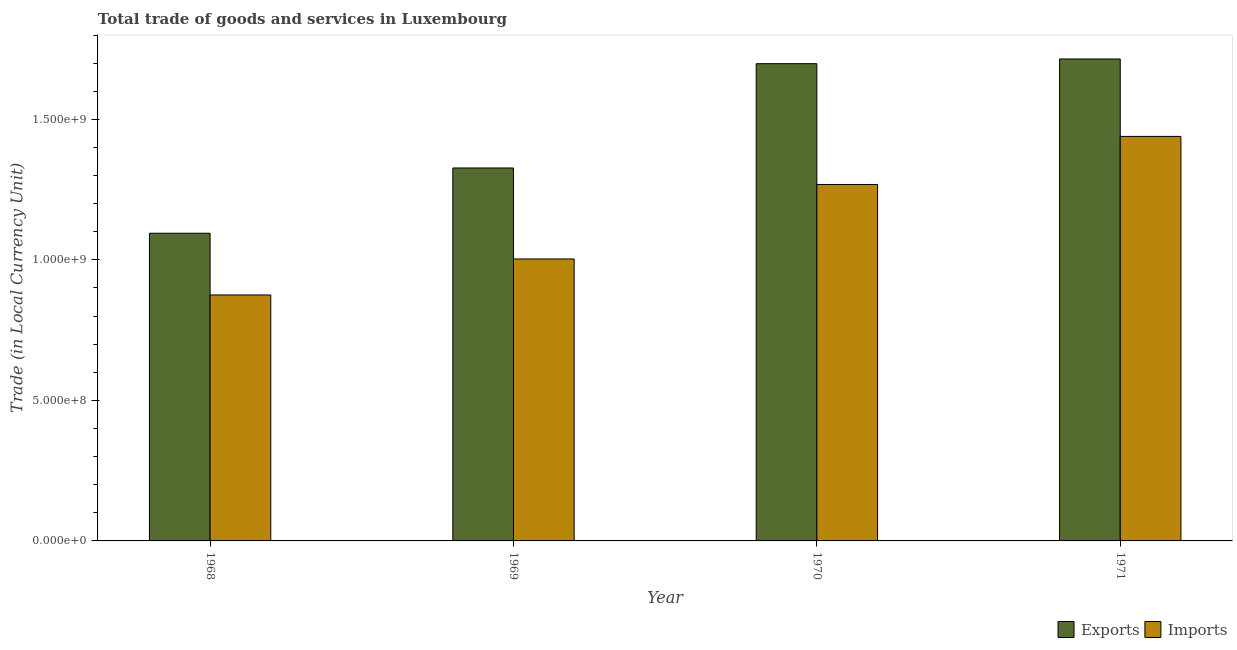How many bars are there on the 1st tick from the right?
Your answer should be very brief. 2. What is the export of goods and services in 1969?
Keep it short and to the point. 1.33e+09. Across all years, what is the maximum imports of goods and services?
Keep it short and to the point. 1.44e+09. Across all years, what is the minimum imports of goods and services?
Your answer should be compact. 8.75e+08. In which year was the imports of goods and services maximum?
Your response must be concise. 1971. In which year was the imports of goods and services minimum?
Your answer should be compact. 1968. What is the total imports of goods and services in the graph?
Make the answer very short. 4.59e+09. What is the difference between the imports of goods and services in 1969 and that in 1971?
Keep it short and to the point. -4.36e+08. What is the difference between the imports of goods and services in 1971 and the export of goods and services in 1970?
Provide a short and direct response. 1.71e+08. What is the average export of goods and services per year?
Your answer should be very brief. 1.46e+09. In how many years, is the export of goods and services greater than 1200000000 LCU?
Offer a very short reply. 3. What is the ratio of the imports of goods and services in 1969 to that in 1970?
Provide a short and direct response. 0.79. Is the export of goods and services in 1969 less than that in 1970?
Provide a succinct answer. Yes. What is the difference between the highest and the second highest imports of goods and services?
Your response must be concise. 1.71e+08. What is the difference between the highest and the lowest imports of goods and services?
Provide a succinct answer. 5.64e+08. In how many years, is the imports of goods and services greater than the average imports of goods and services taken over all years?
Provide a succinct answer. 2. What does the 2nd bar from the left in 1968 represents?
Your response must be concise. Imports. What does the 1st bar from the right in 1970 represents?
Keep it short and to the point. Imports. Are all the bars in the graph horizontal?
Give a very brief answer. No. What is the difference between two consecutive major ticks on the Y-axis?
Give a very brief answer. 5.00e+08. Are the values on the major ticks of Y-axis written in scientific E-notation?
Keep it short and to the point. Yes. Does the graph contain any zero values?
Offer a very short reply. No. Where does the legend appear in the graph?
Your answer should be very brief. Bottom right. How many legend labels are there?
Give a very brief answer. 2. How are the legend labels stacked?
Make the answer very short. Horizontal. What is the title of the graph?
Your response must be concise. Total trade of goods and services in Luxembourg. What is the label or title of the X-axis?
Your answer should be compact. Year. What is the label or title of the Y-axis?
Give a very brief answer. Trade (in Local Currency Unit). What is the Trade (in Local Currency Unit) of Exports in 1968?
Provide a short and direct response. 1.09e+09. What is the Trade (in Local Currency Unit) in Imports in 1968?
Give a very brief answer. 8.75e+08. What is the Trade (in Local Currency Unit) of Exports in 1969?
Provide a succinct answer. 1.33e+09. What is the Trade (in Local Currency Unit) of Imports in 1969?
Offer a terse response. 1.00e+09. What is the Trade (in Local Currency Unit) of Exports in 1970?
Provide a succinct answer. 1.70e+09. What is the Trade (in Local Currency Unit) in Imports in 1970?
Make the answer very short. 1.27e+09. What is the Trade (in Local Currency Unit) in Exports in 1971?
Provide a short and direct response. 1.71e+09. What is the Trade (in Local Currency Unit) in Imports in 1971?
Offer a very short reply. 1.44e+09. Across all years, what is the maximum Trade (in Local Currency Unit) in Exports?
Keep it short and to the point. 1.71e+09. Across all years, what is the maximum Trade (in Local Currency Unit) in Imports?
Your answer should be compact. 1.44e+09. Across all years, what is the minimum Trade (in Local Currency Unit) of Exports?
Give a very brief answer. 1.09e+09. Across all years, what is the minimum Trade (in Local Currency Unit) in Imports?
Provide a short and direct response. 8.75e+08. What is the total Trade (in Local Currency Unit) of Exports in the graph?
Your answer should be very brief. 5.84e+09. What is the total Trade (in Local Currency Unit) of Imports in the graph?
Ensure brevity in your answer.  4.59e+09. What is the difference between the Trade (in Local Currency Unit) of Exports in 1968 and that in 1969?
Your answer should be compact. -2.32e+08. What is the difference between the Trade (in Local Currency Unit) in Imports in 1968 and that in 1969?
Make the answer very short. -1.28e+08. What is the difference between the Trade (in Local Currency Unit) in Exports in 1968 and that in 1970?
Your answer should be compact. -6.03e+08. What is the difference between the Trade (in Local Currency Unit) in Imports in 1968 and that in 1970?
Provide a succinct answer. -3.93e+08. What is the difference between the Trade (in Local Currency Unit) of Exports in 1968 and that in 1971?
Your response must be concise. -6.20e+08. What is the difference between the Trade (in Local Currency Unit) of Imports in 1968 and that in 1971?
Provide a short and direct response. -5.64e+08. What is the difference between the Trade (in Local Currency Unit) of Exports in 1969 and that in 1970?
Provide a succinct answer. -3.71e+08. What is the difference between the Trade (in Local Currency Unit) of Imports in 1969 and that in 1970?
Offer a terse response. -2.65e+08. What is the difference between the Trade (in Local Currency Unit) in Exports in 1969 and that in 1971?
Give a very brief answer. -3.88e+08. What is the difference between the Trade (in Local Currency Unit) in Imports in 1969 and that in 1971?
Ensure brevity in your answer.  -4.36e+08. What is the difference between the Trade (in Local Currency Unit) of Exports in 1970 and that in 1971?
Provide a short and direct response. -1.67e+07. What is the difference between the Trade (in Local Currency Unit) in Imports in 1970 and that in 1971?
Keep it short and to the point. -1.71e+08. What is the difference between the Trade (in Local Currency Unit) of Exports in 1968 and the Trade (in Local Currency Unit) of Imports in 1969?
Make the answer very short. 9.15e+07. What is the difference between the Trade (in Local Currency Unit) in Exports in 1968 and the Trade (in Local Currency Unit) in Imports in 1970?
Ensure brevity in your answer.  -1.74e+08. What is the difference between the Trade (in Local Currency Unit) of Exports in 1968 and the Trade (in Local Currency Unit) of Imports in 1971?
Keep it short and to the point. -3.45e+08. What is the difference between the Trade (in Local Currency Unit) in Exports in 1969 and the Trade (in Local Currency Unit) in Imports in 1970?
Make the answer very short. 5.87e+07. What is the difference between the Trade (in Local Currency Unit) in Exports in 1969 and the Trade (in Local Currency Unit) in Imports in 1971?
Your answer should be compact. -1.12e+08. What is the difference between the Trade (in Local Currency Unit) of Exports in 1970 and the Trade (in Local Currency Unit) of Imports in 1971?
Your answer should be very brief. 2.59e+08. What is the average Trade (in Local Currency Unit) in Exports per year?
Your answer should be compact. 1.46e+09. What is the average Trade (in Local Currency Unit) in Imports per year?
Offer a very short reply. 1.15e+09. In the year 1968, what is the difference between the Trade (in Local Currency Unit) of Exports and Trade (in Local Currency Unit) of Imports?
Ensure brevity in your answer.  2.20e+08. In the year 1969, what is the difference between the Trade (in Local Currency Unit) in Exports and Trade (in Local Currency Unit) in Imports?
Keep it short and to the point. 3.24e+08. In the year 1970, what is the difference between the Trade (in Local Currency Unit) in Exports and Trade (in Local Currency Unit) in Imports?
Offer a very short reply. 4.30e+08. In the year 1971, what is the difference between the Trade (in Local Currency Unit) in Exports and Trade (in Local Currency Unit) in Imports?
Offer a very short reply. 2.76e+08. What is the ratio of the Trade (in Local Currency Unit) in Exports in 1968 to that in 1969?
Your response must be concise. 0.82. What is the ratio of the Trade (in Local Currency Unit) of Imports in 1968 to that in 1969?
Make the answer very short. 0.87. What is the ratio of the Trade (in Local Currency Unit) of Exports in 1968 to that in 1970?
Give a very brief answer. 0.64. What is the ratio of the Trade (in Local Currency Unit) in Imports in 1968 to that in 1970?
Keep it short and to the point. 0.69. What is the ratio of the Trade (in Local Currency Unit) in Exports in 1968 to that in 1971?
Provide a succinct answer. 0.64. What is the ratio of the Trade (in Local Currency Unit) in Imports in 1968 to that in 1971?
Provide a succinct answer. 0.61. What is the ratio of the Trade (in Local Currency Unit) of Exports in 1969 to that in 1970?
Your response must be concise. 0.78. What is the ratio of the Trade (in Local Currency Unit) of Imports in 1969 to that in 1970?
Provide a short and direct response. 0.79. What is the ratio of the Trade (in Local Currency Unit) of Exports in 1969 to that in 1971?
Your answer should be compact. 0.77. What is the ratio of the Trade (in Local Currency Unit) in Imports in 1969 to that in 1971?
Ensure brevity in your answer.  0.7. What is the ratio of the Trade (in Local Currency Unit) in Exports in 1970 to that in 1971?
Offer a very short reply. 0.99. What is the ratio of the Trade (in Local Currency Unit) in Imports in 1970 to that in 1971?
Your response must be concise. 0.88. What is the difference between the highest and the second highest Trade (in Local Currency Unit) of Exports?
Keep it short and to the point. 1.67e+07. What is the difference between the highest and the second highest Trade (in Local Currency Unit) in Imports?
Provide a succinct answer. 1.71e+08. What is the difference between the highest and the lowest Trade (in Local Currency Unit) of Exports?
Your response must be concise. 6.20e+08. What is the difference between the highest and the lowest Trade (in Local Currency Unit) of Imports?
Offer a very short reply. 5.64e+08. 